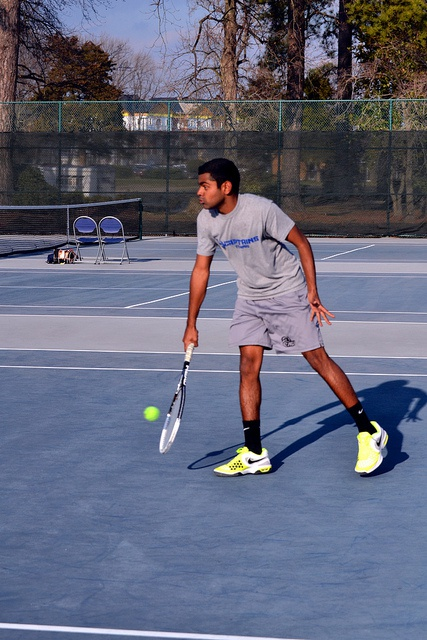Describe the objects in this image and their specific colors. I can see people in gray, darkgray, black, and brown tones, tennis racket in gray, darkgray, white, and black tones, chair in gray and black tones, chair in gray, black, blue, navy, and darkgray tones, and sports ball in gray, lightgreen, yellow, and green tones in this image. 